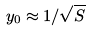Convert formula to latex. <formula><loc_0><loc_0><loc_500><loc_500>y _ { 0 } \approx 1 / \sqrt { S }</formula> 